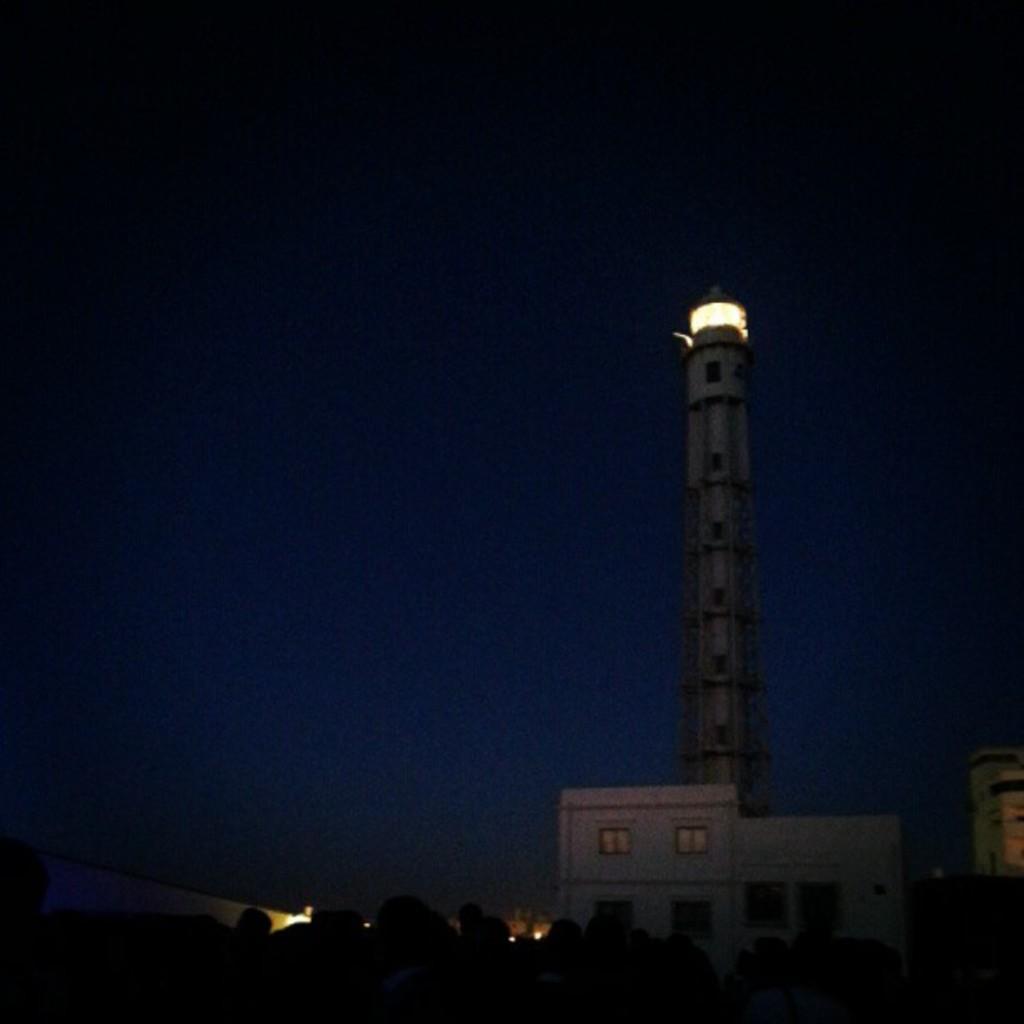How would you summarize this image in a sentence or two? In this image, we can see lighthouse and buildings. At the bottom, we can see dark view. Background we can see the sky. 